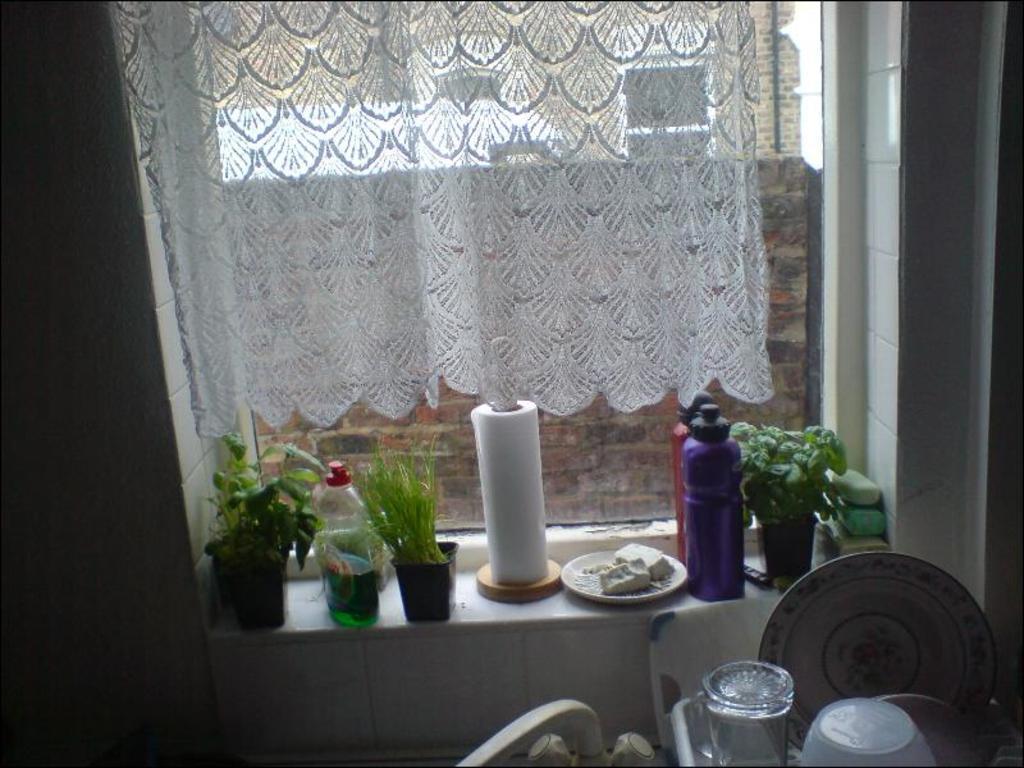Please provide a concise description of this image. In a room there is a window with the curtain with the flower pots and some bottles along with the tissue roll beside that there is a table with glass plates and bowls in it. 